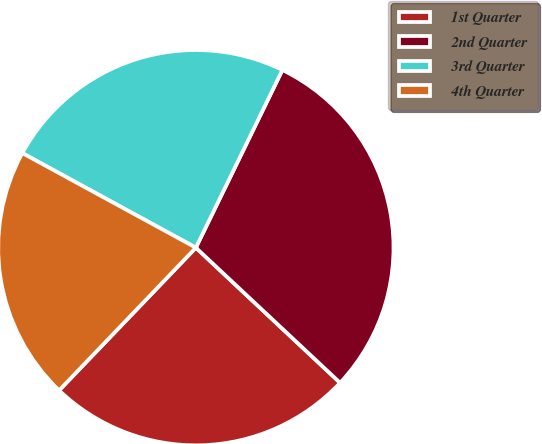<chart> <loc_0><loc_0><loc_500><loc_500><pie_chart><fcel>1st Quarter<fcel>2nd Quarter<fcel>3rd Quarter<fcel>4th Quarter<nl><fcel>25.18%<fcel>29.77%<fcel>24.27%<fcel>20.78%<nl></chart> 